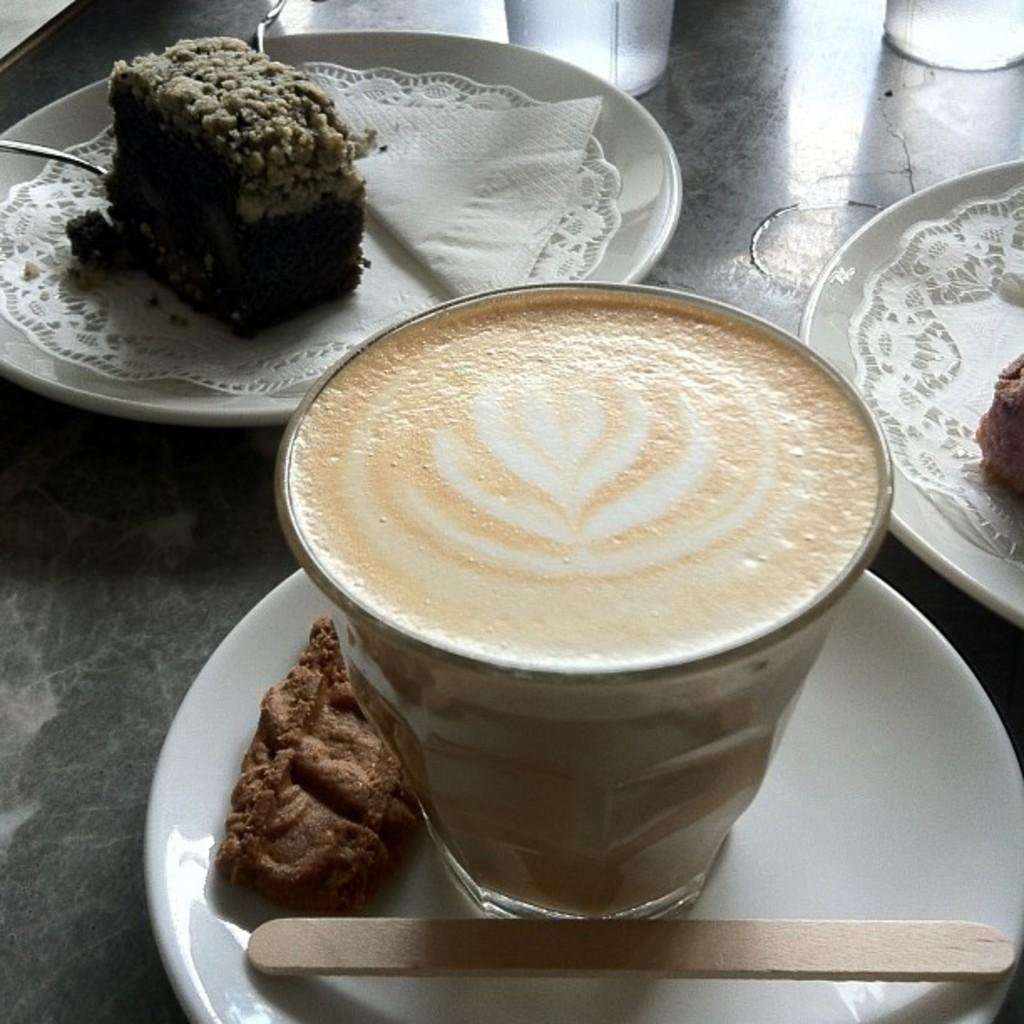What piece of furniture is present in the image? There is a table in the image. What beverage is on the table? There is a coffee on the table. What type of container is holding the coffee? There is a cup on the table. What object might be used to stir the coffee? There is a stick (possibly a stirrer) on the table. What item is available for wiping or blowing one's nose? There is a tissue on the table. What type of food is present on the table? There is a sweet on the table. Where is the stove located in the image? There is no stove present in the image. What impulse might the person have to consume the coffee quickly? The image does not provide any information about the person's impulses or motivations for consuming the coffee. 